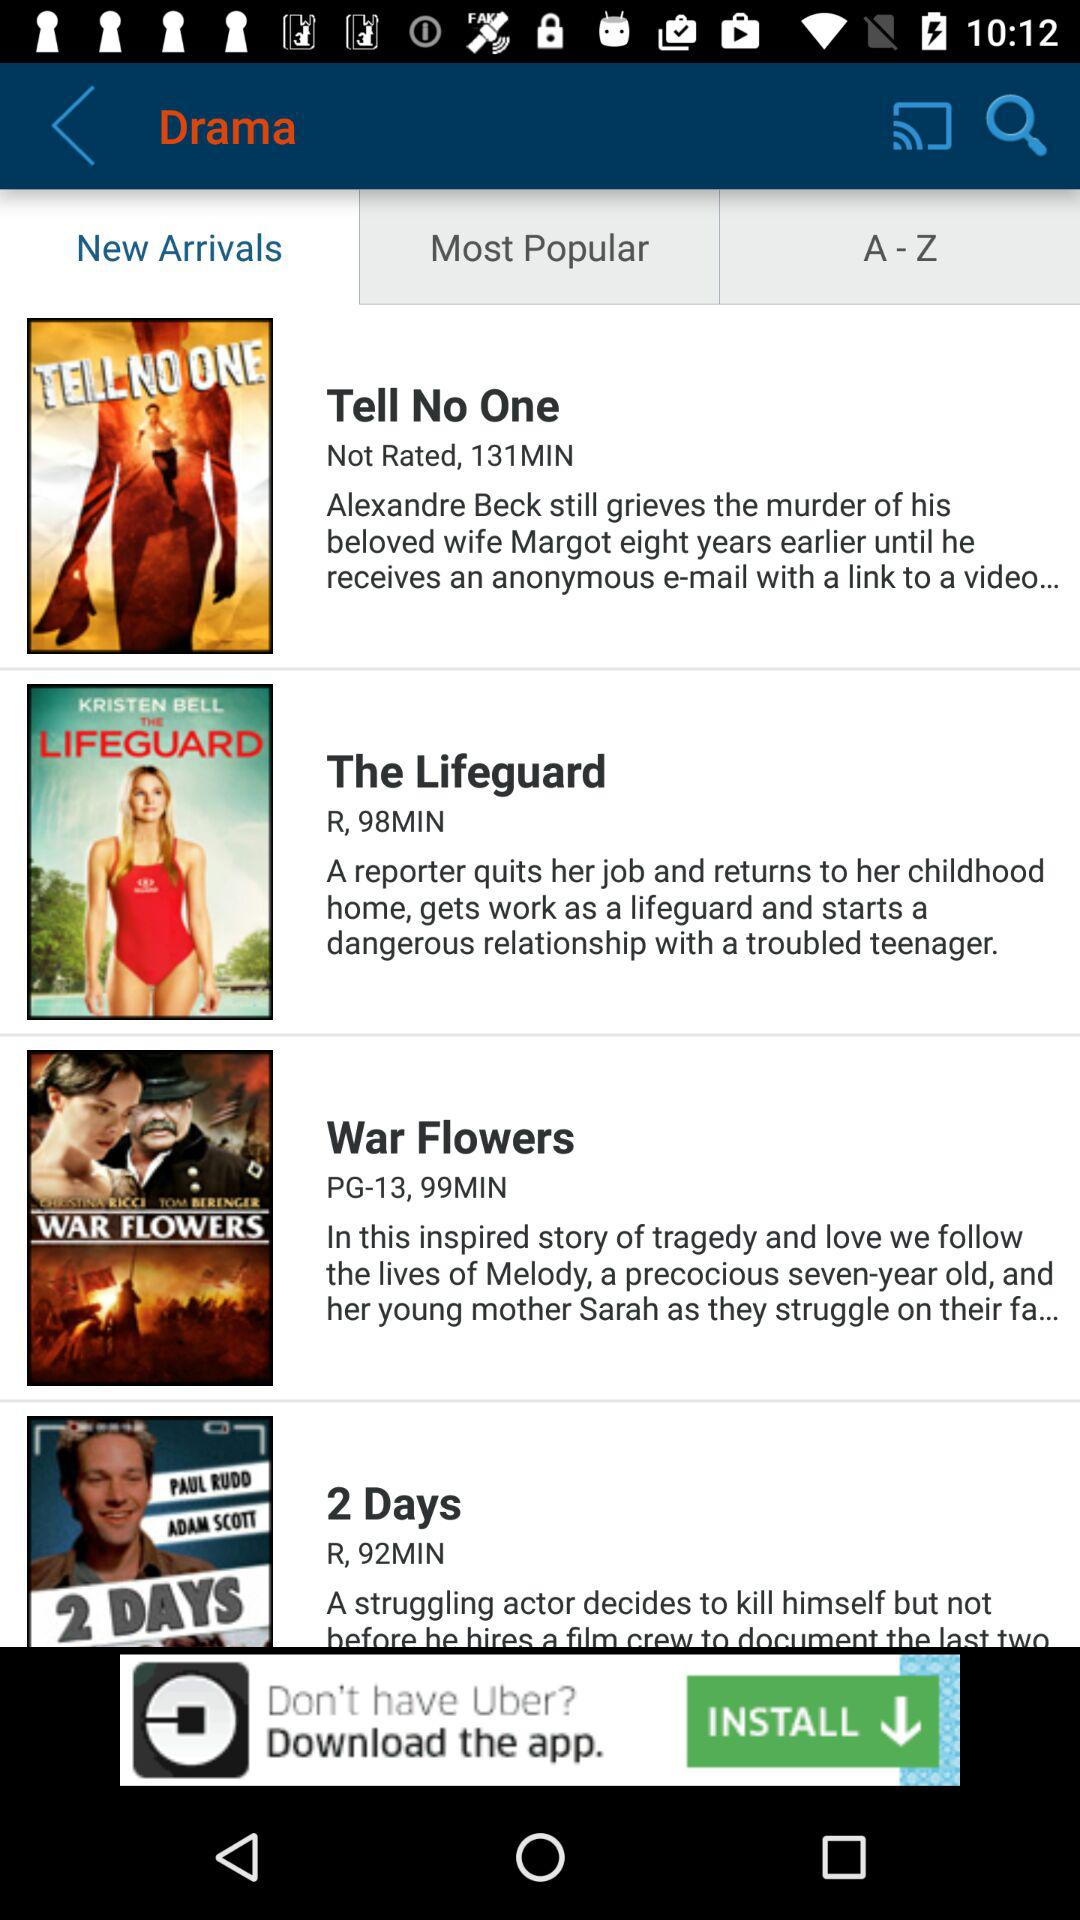What is the rating of the drama The Lifeguard?
When the provided information is insufficient, respond with <no answer>. <no answer> 